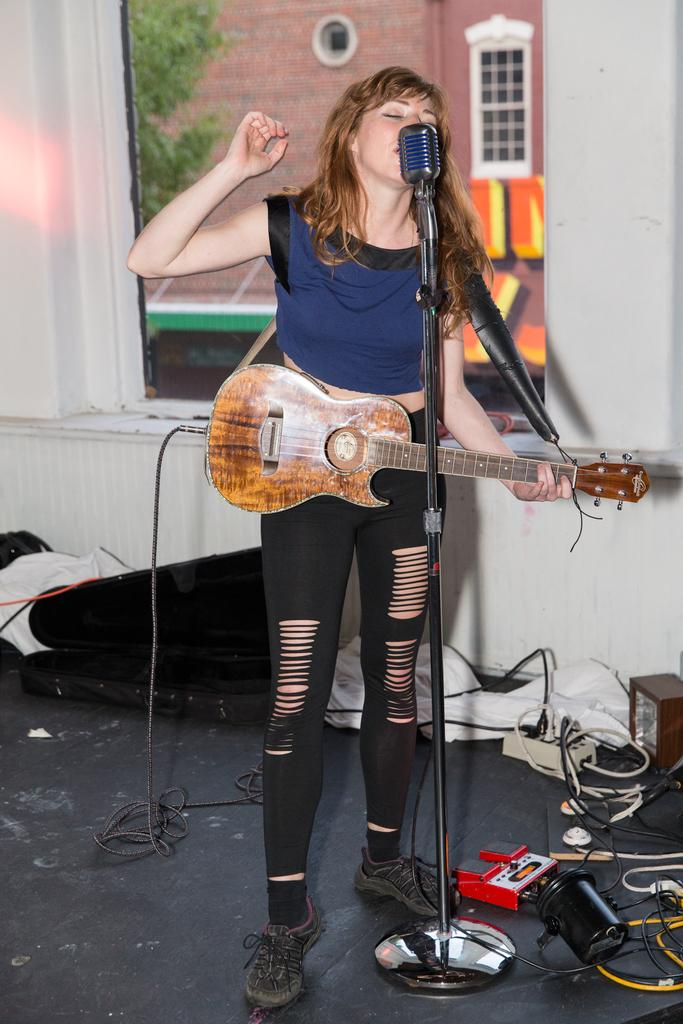Who is the main subject in the image? There is a woman in the image. What is the woman doing in the image? The woman is standing in the image. What object is the woman holding in her hand? The woman is holding a guitar in her hand. What device is in front of the woman? There is a microphone (mic) in front of the woman. What type of pen can be seen in the woman's pocket in the image? There is no pen or pocket visible in the image; the woman is holding a guitar and standing in front of a microphone. 